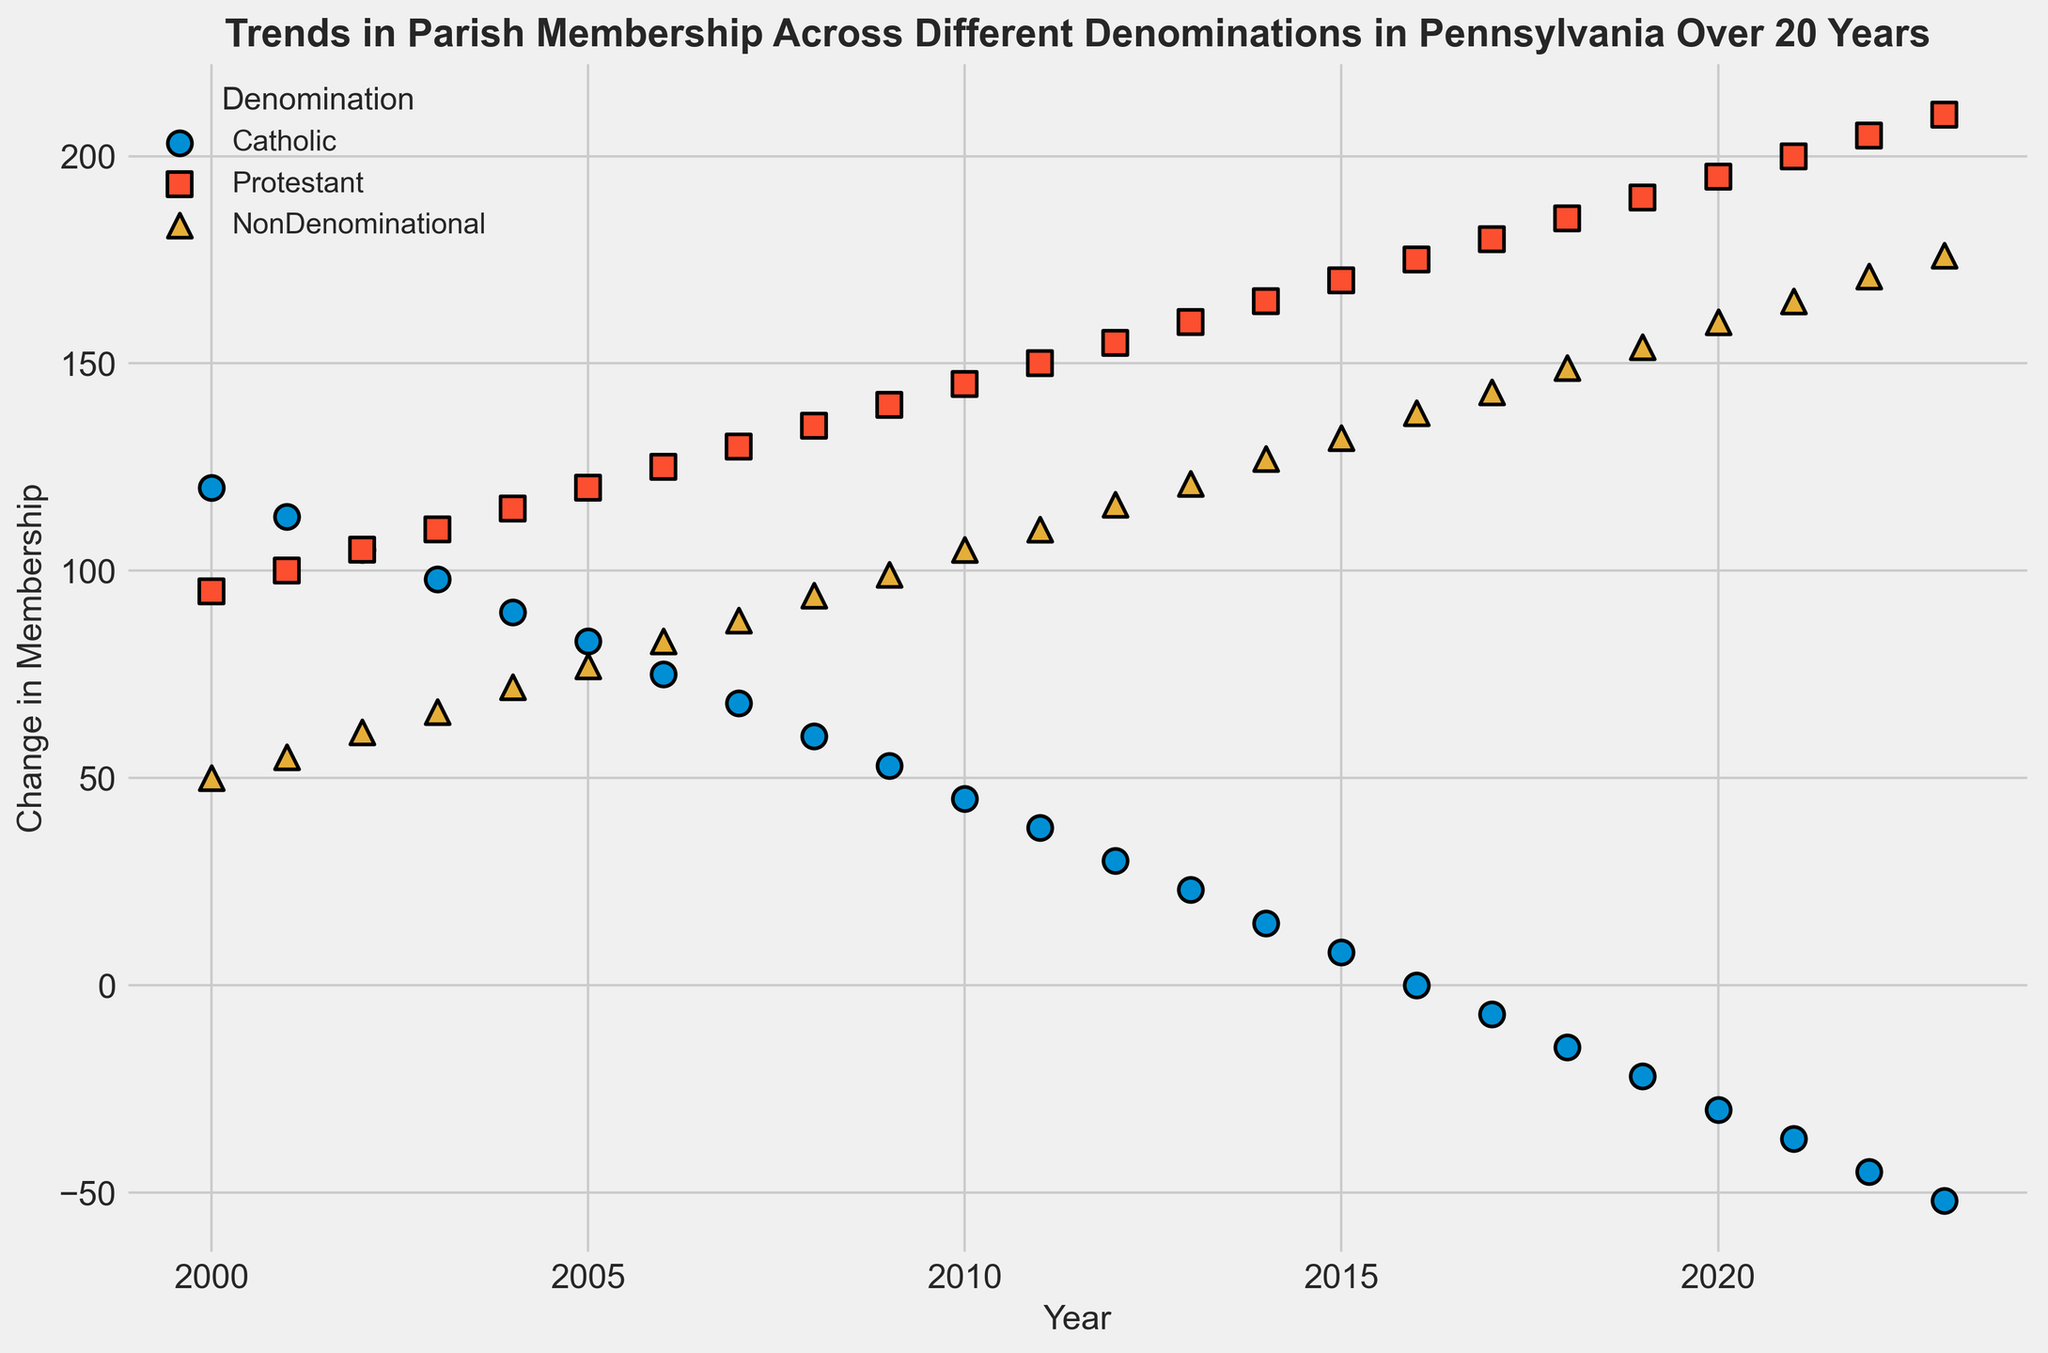What trend do the Catholic membership numbers show over the 20-year period? The plot shows a consistent decline in the Catholic membership numbers, starting from positive values in the year 2000 and gradually decreasing to negative values by 2023.
Answer: Declining Which denomination shows the highest increase in membership over the 20-year period? By comparing the scatter plot points for each denomination, we see that the Protestant denomination shows a steady increase, starting at 95 in 2000 and reaching 210 in 2023.
Answer: Protestant Between 2000 and 2010, how did the Catholic and NonDenominational membership trends compare? The Catholic membership showed a decline from 120 to 45, while the NonDenominational membership showed an increase from 50 to 105.
Answer: Catholic decreased, NonDenominational increased What is the membership change value for Protestants in the year 2023? The scatter plot point for Protestants in 2023 is positioned at approximately 210 on the y-axis.
Answer: 210 In what year did the Catholics first experience a negative change in membership? Observing the Catholic trend line, the first negative value appears in the year 2017 with a change of -7.
Answer: 2017 How does the growth rate of NonDenominational compare to Protestant from 2015 to 2020? For NonDenominational, the membership change increases from 132 to 160, a growth of 28. For Protestant, the membership change increases from 170 to 195, a growth of 25. NonDenominational has a slightly higher growth rate in this period.
Answer: NonDenominational grows slightly faster During the period from 2000 to 2023, which denomination shows the most stable trend in membership change? The Protestant denomination shows a relatively stable trend, with a steady increase in membership each year without any fluctuations or drops.
Answer: Protestant What visual differences can be observed between the Catholic and NonDenominational trends in the scatter plot? The Catholic trend shows a downward trajectory with negative values starting in the latter years, while the NonDenominational trend is consistently upward and remains positive throughout the 20 years.
Answer: Catholic downward, NonDenominational upward What is the average membership change for Catholics from 2000 to 2023? Sum the Catholic membership changes: 120 + 113 + 105 + 98 + 90 + 83 + 75 + 68 + 60 + 53 + 45 + 38 + 30 + 23 + 15 + 8 + 0 + (-7) + (-15) + (-22) + (-30) + (-37) + (-45) + (-52) = 678. There are 24 years: 678/24 = 28.25.
Answer: 28.25 